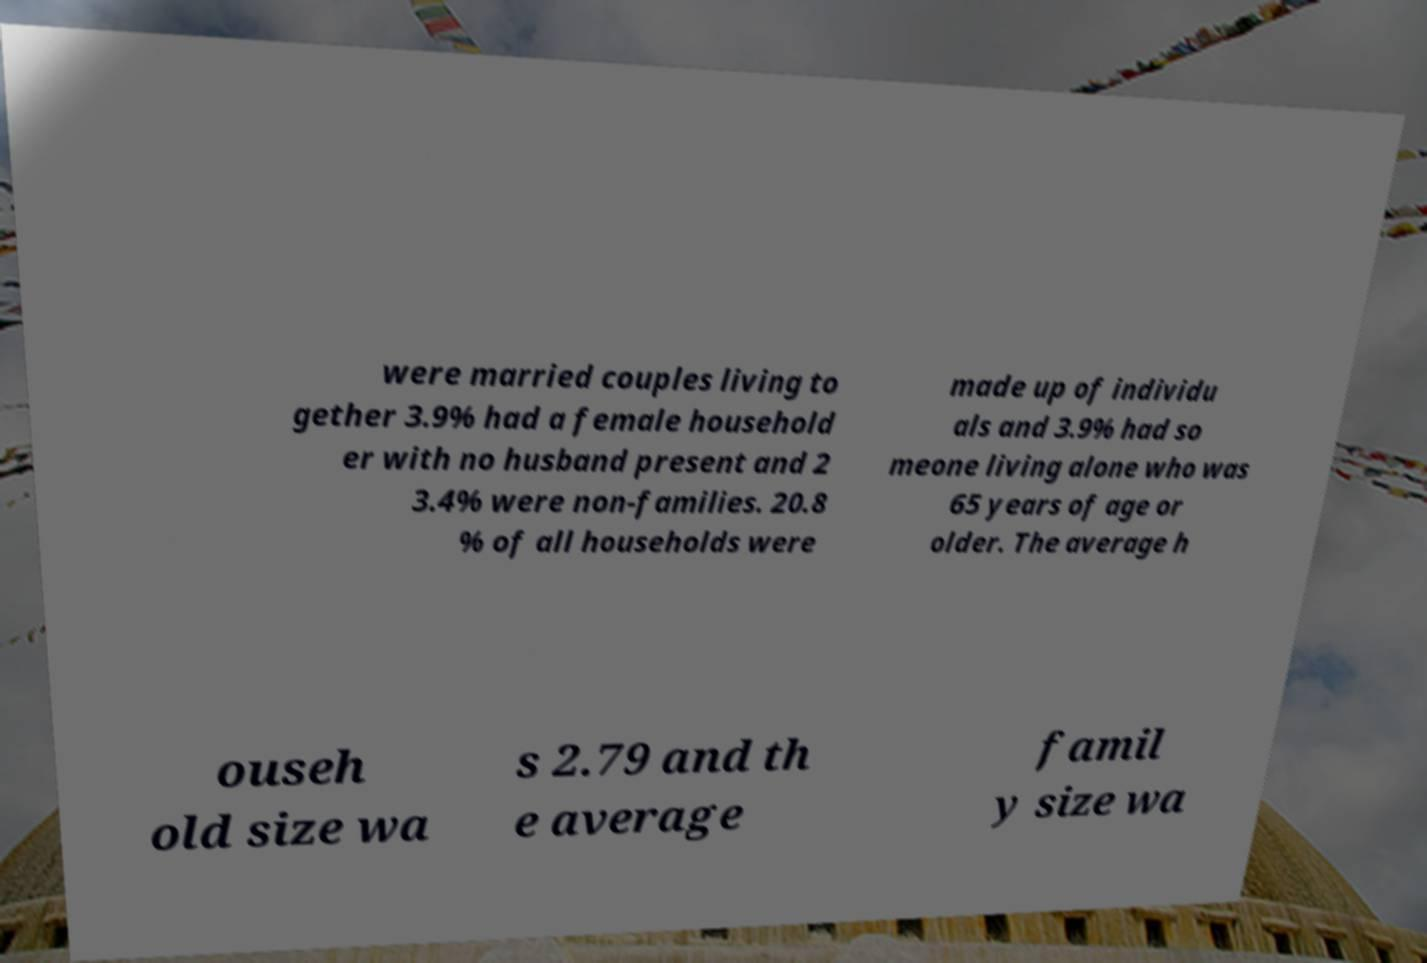Please read and relay the text visible in this image. What does it say? were married couples living to gether 3.9% had a female household er with no husband present and 2 3.4% were non-families. 20.8 % of all households were made up of individu als and 3.9% had so meone living alone who was 65 years of age or older. The average h ouseh old size wa s 2.79 and th e average famil y size wa 